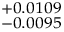<formula> <loc_0><loc_0><loc_500><loc_500>^ { + 0 . 0 1 0 9 } _ { - 0 . 0 0 9 5 }</formula> 